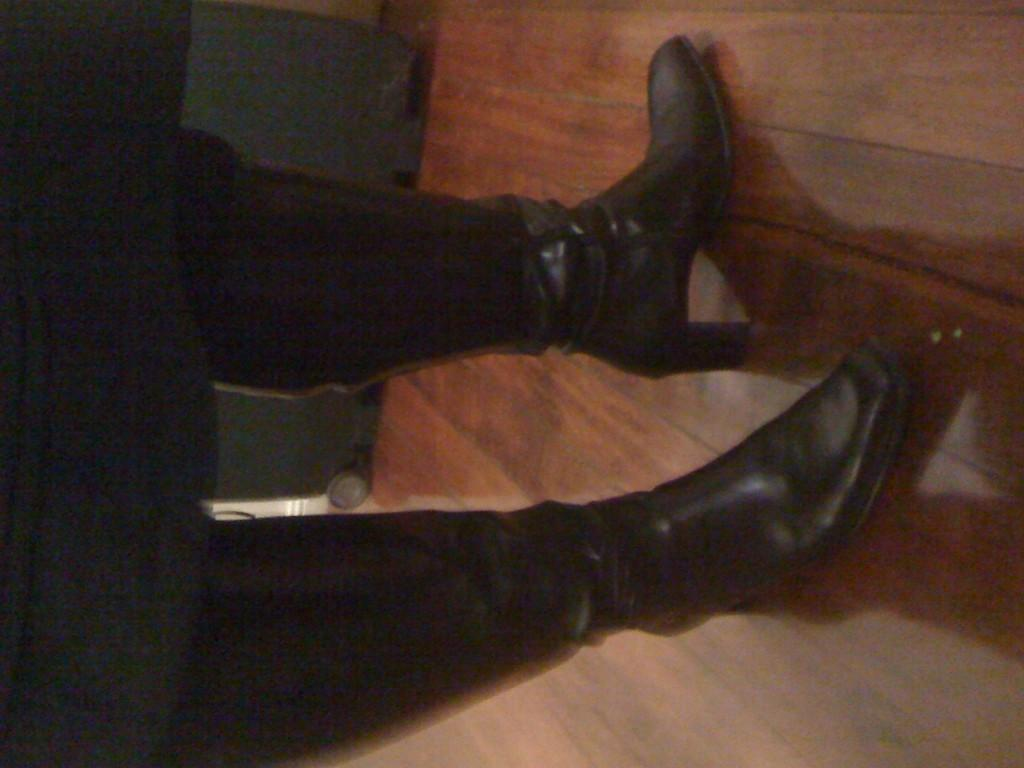What can be seen in the image? There is a person in the image. What type of shoe is the person wearing? The person is wearing a black shoe. What is the surface the person is standing on? The person is standing on a wooden floor. Where is the person located in the image? The person is standing in the middle of the image. What type of suit is the person wearing in the image? There is no suit visible in the image; the person is only wearing a black shoe. What beliefs does the person in the image hold? There is no information about the person's beliefs in the image. 